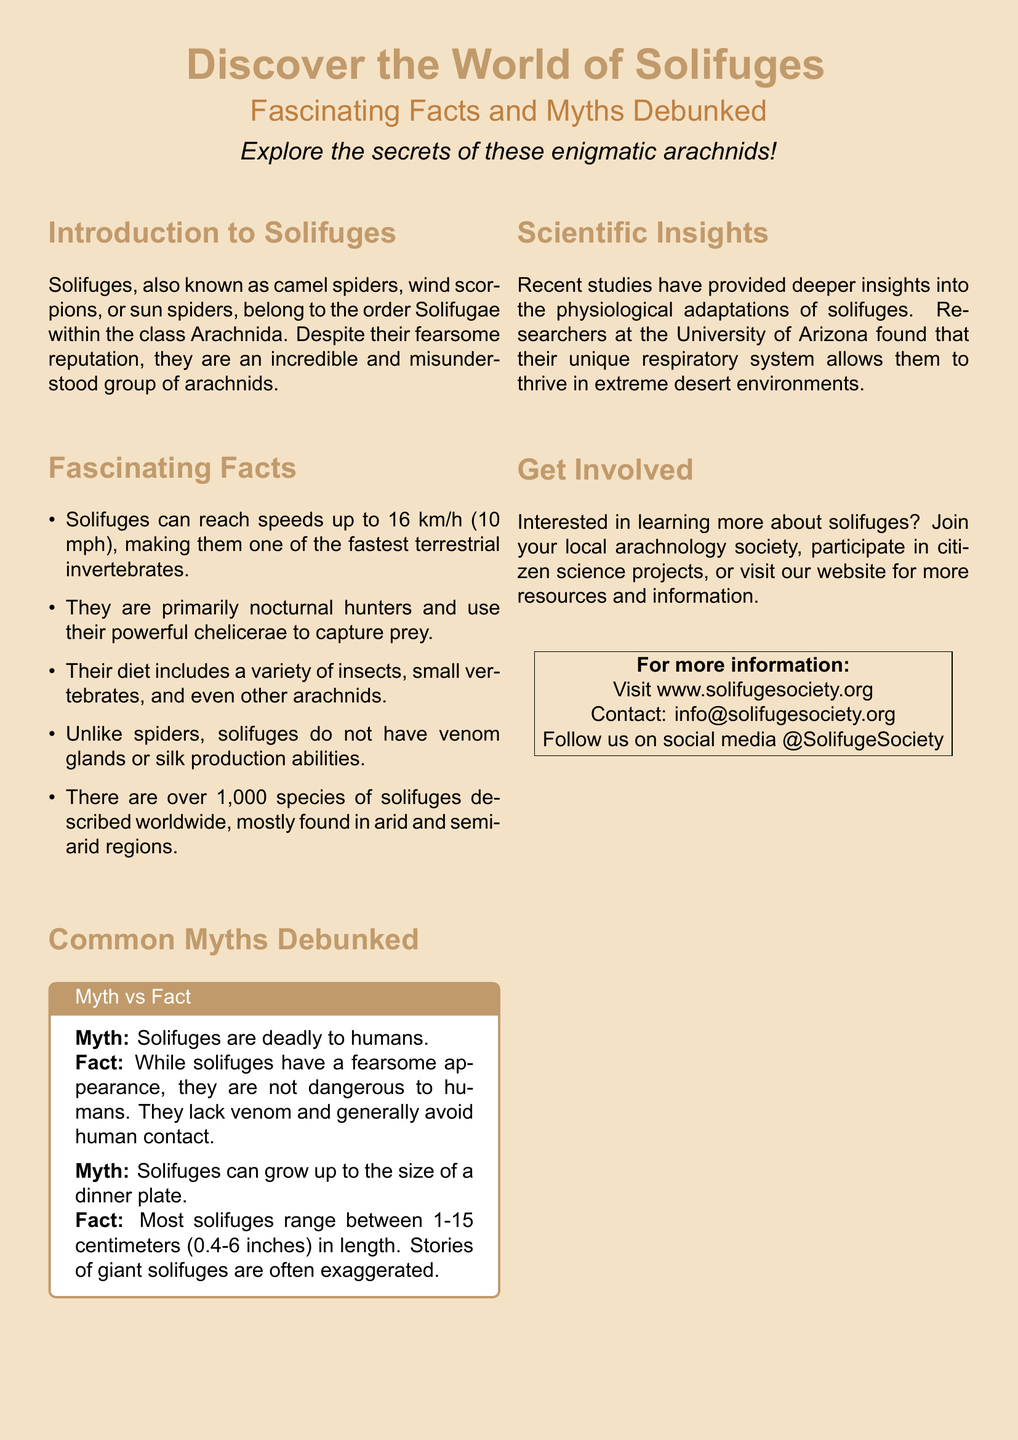What is the order to which solifuges belong? The document states that solifuges belong to the order Solifugae.
Answer: Solifugae How fast can solifuges reach? The document mentions that solifuges can reach speeds up to 16 km/h (10 mph).
Answer: 16 km/h (10 mph) What type of diet do solifuges have? The document provides information that solifuges have a diet including insects, small vertebrates, and other arachnids.
Answer: Insects, small vertebrates, and other arachnids What is a common myth about solifuges? The document lists myths, one of which is that solifuges are deadly to humans.
Answer: Solifuges are deadly to humans What scientific insight was mentioned in the document? The document highlights recent studies about their unique respiratory system in extreme desert environments.
Answer: Unique respiratory system What organization can you contact for more information? The document provides a contact email for the solifuge society for more information.
Answer: info@solifugesociety.org How many species of solifuges are described worldwide? The document states that there are over 1,000 species of solifuges described.
Answer: Over 1,000 species What is one way to get involved with solifuges? The document suggests joining a local arachnology society as a way to get involved.
Answer: Join your local arachnology society 